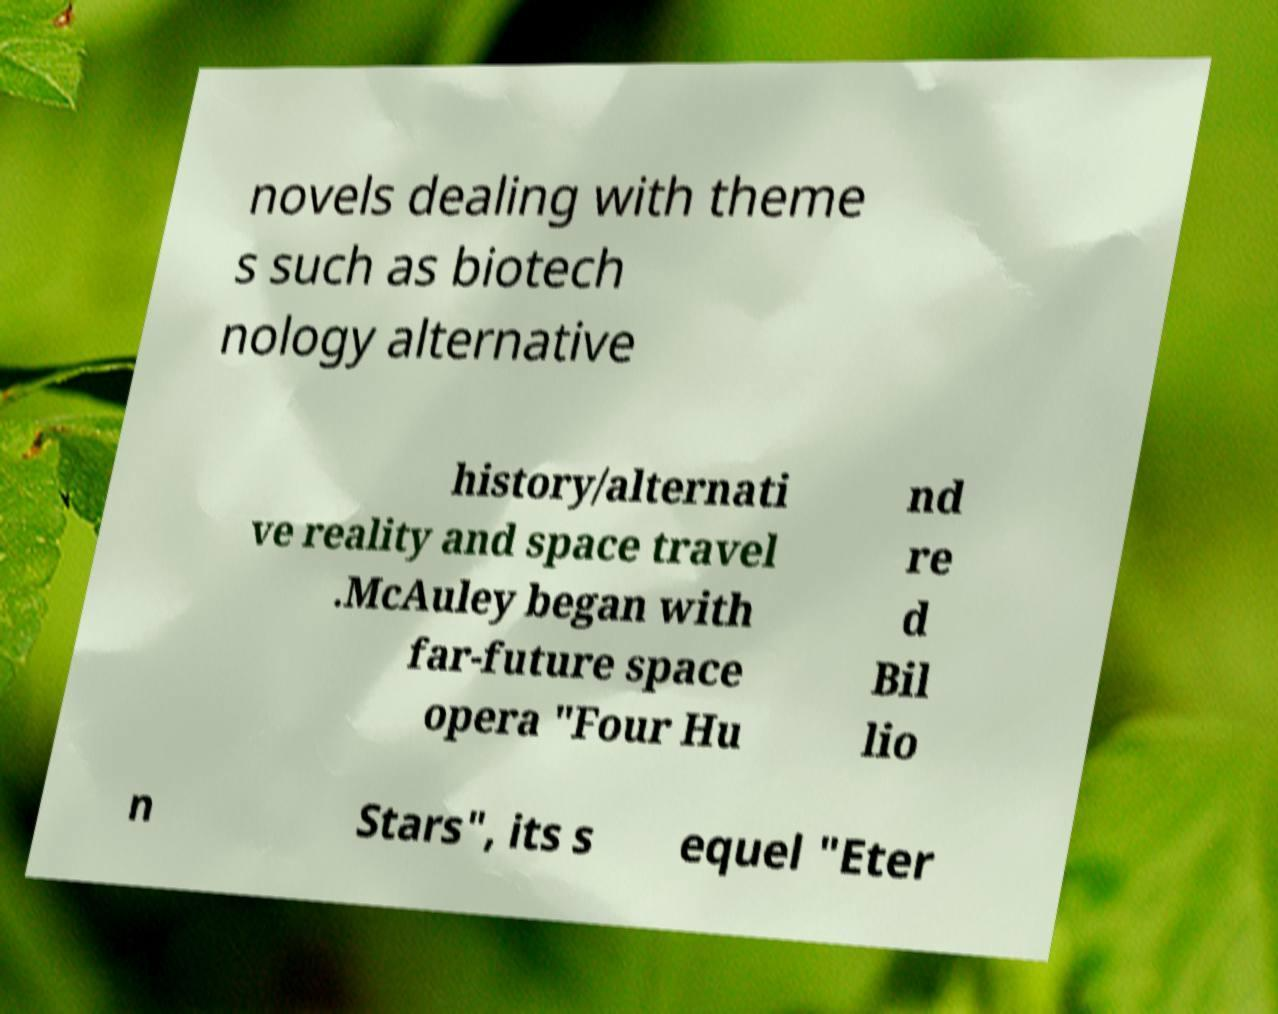Could you extract and type out the text from this image? novels dealing with theme s such as biotech nology alternative history/alternati ve reality and space travel .McAuley began with far-future space opera "Four Hu nd re d Bil lio n Stars", its s equel "Eter 